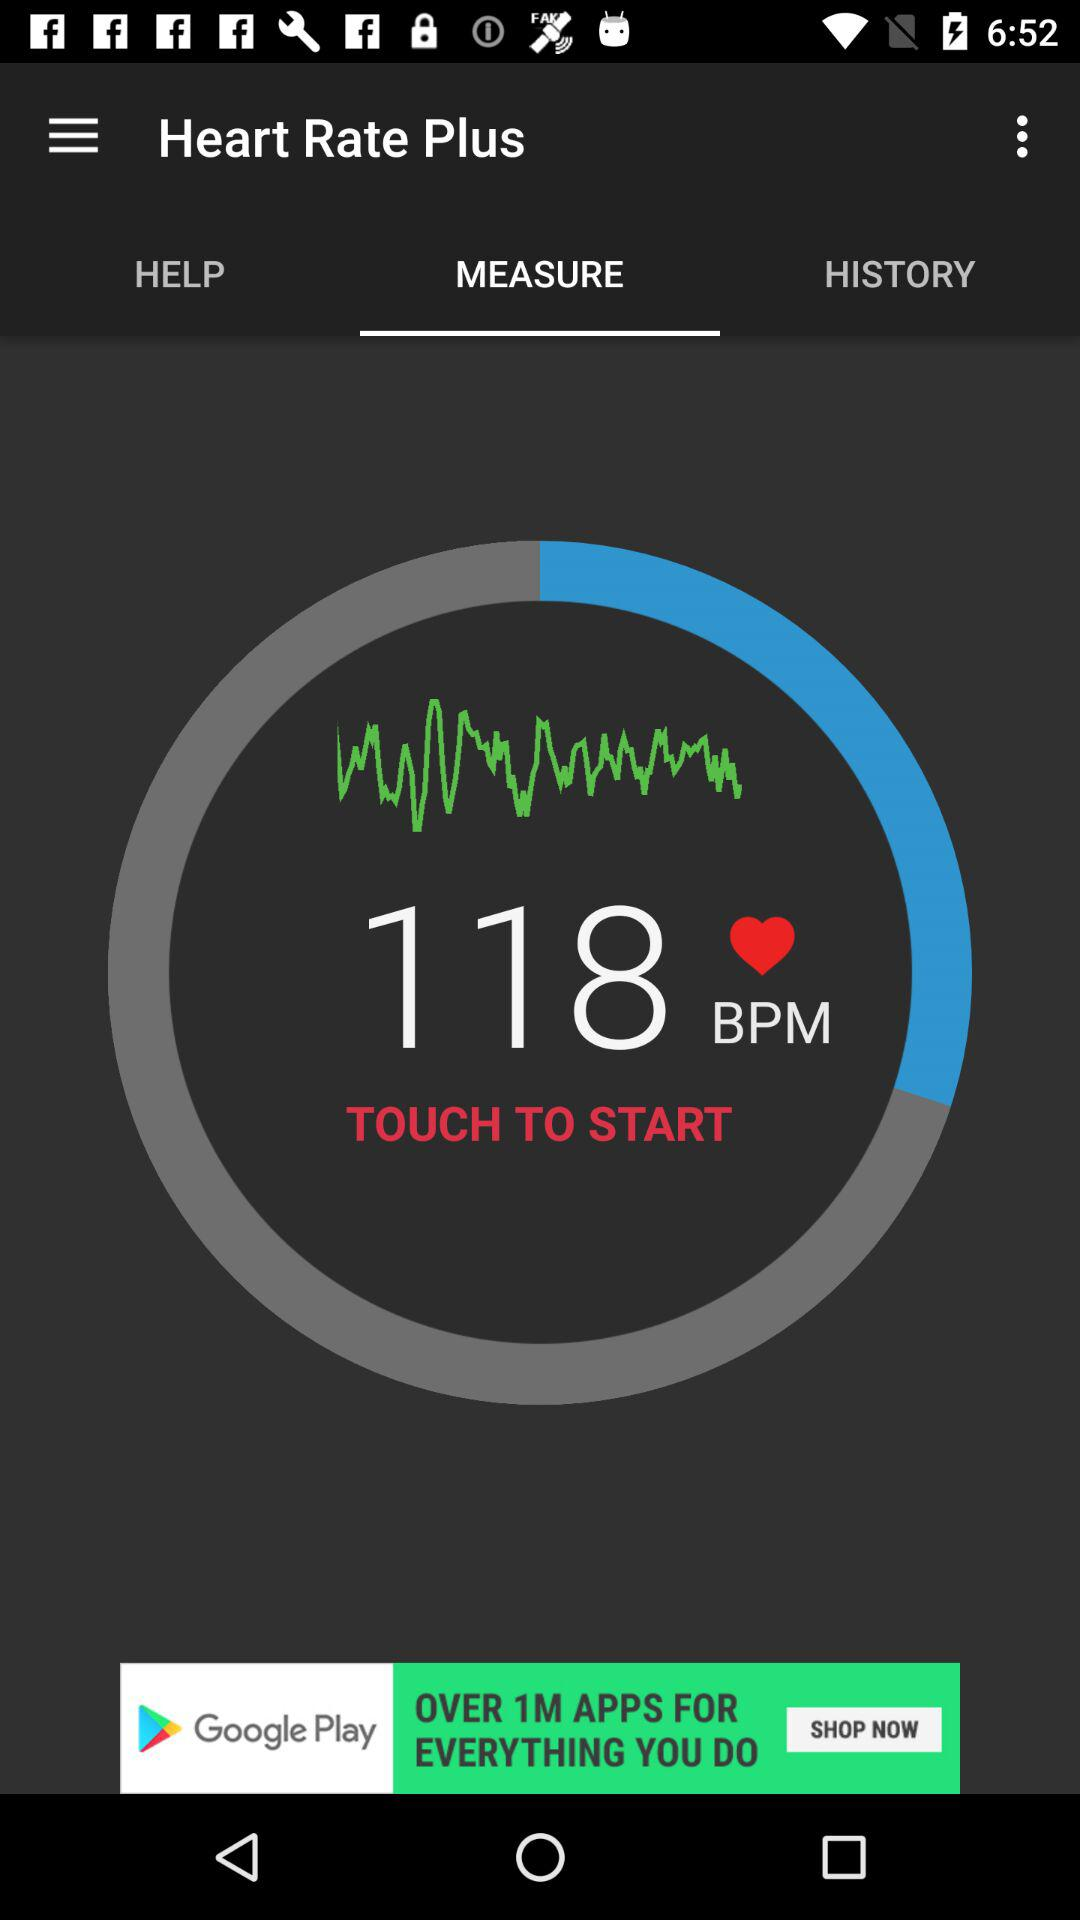How many bpm is the heart rate displayed?
Answer the question using a single word or phrase. 118 